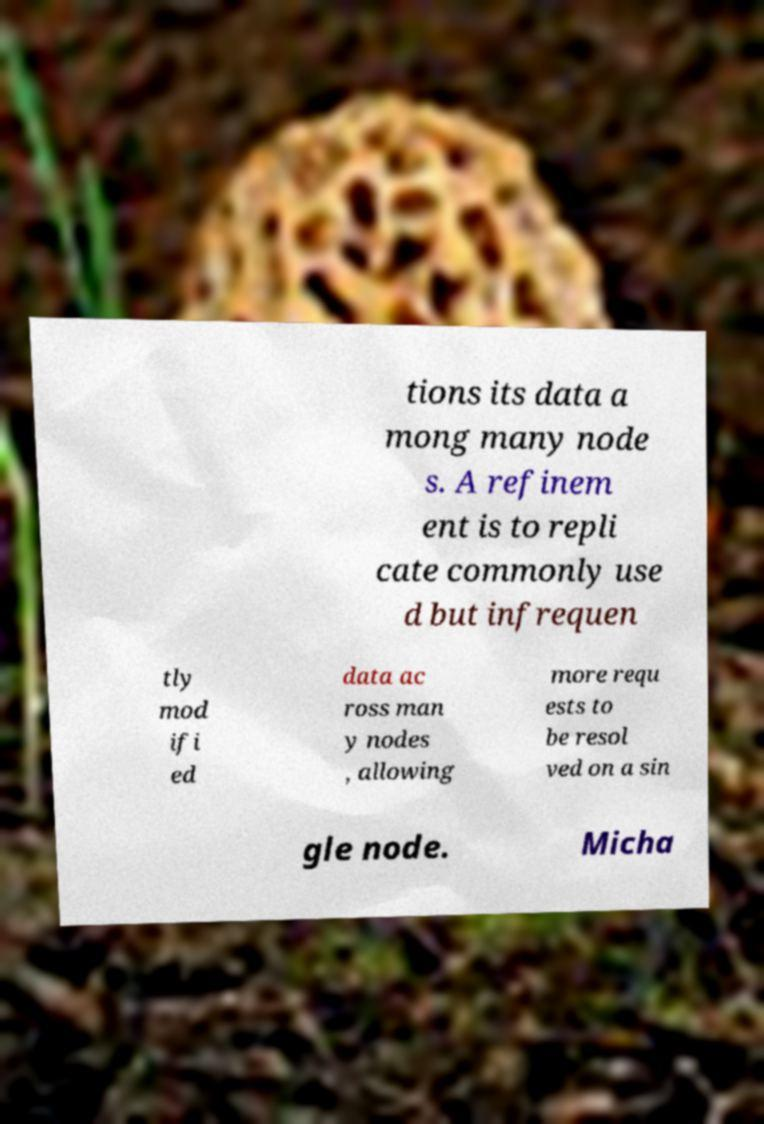Could you assist in decoding the text presented in this image and type it out clearly? tions its data a mong many node s. A refinem ent is to repli cate commonly use d but infrequen tly mod ifi ed data ac ross man y nodes , allowing more requ ests to be resol ved on a sin gle node. Micha 